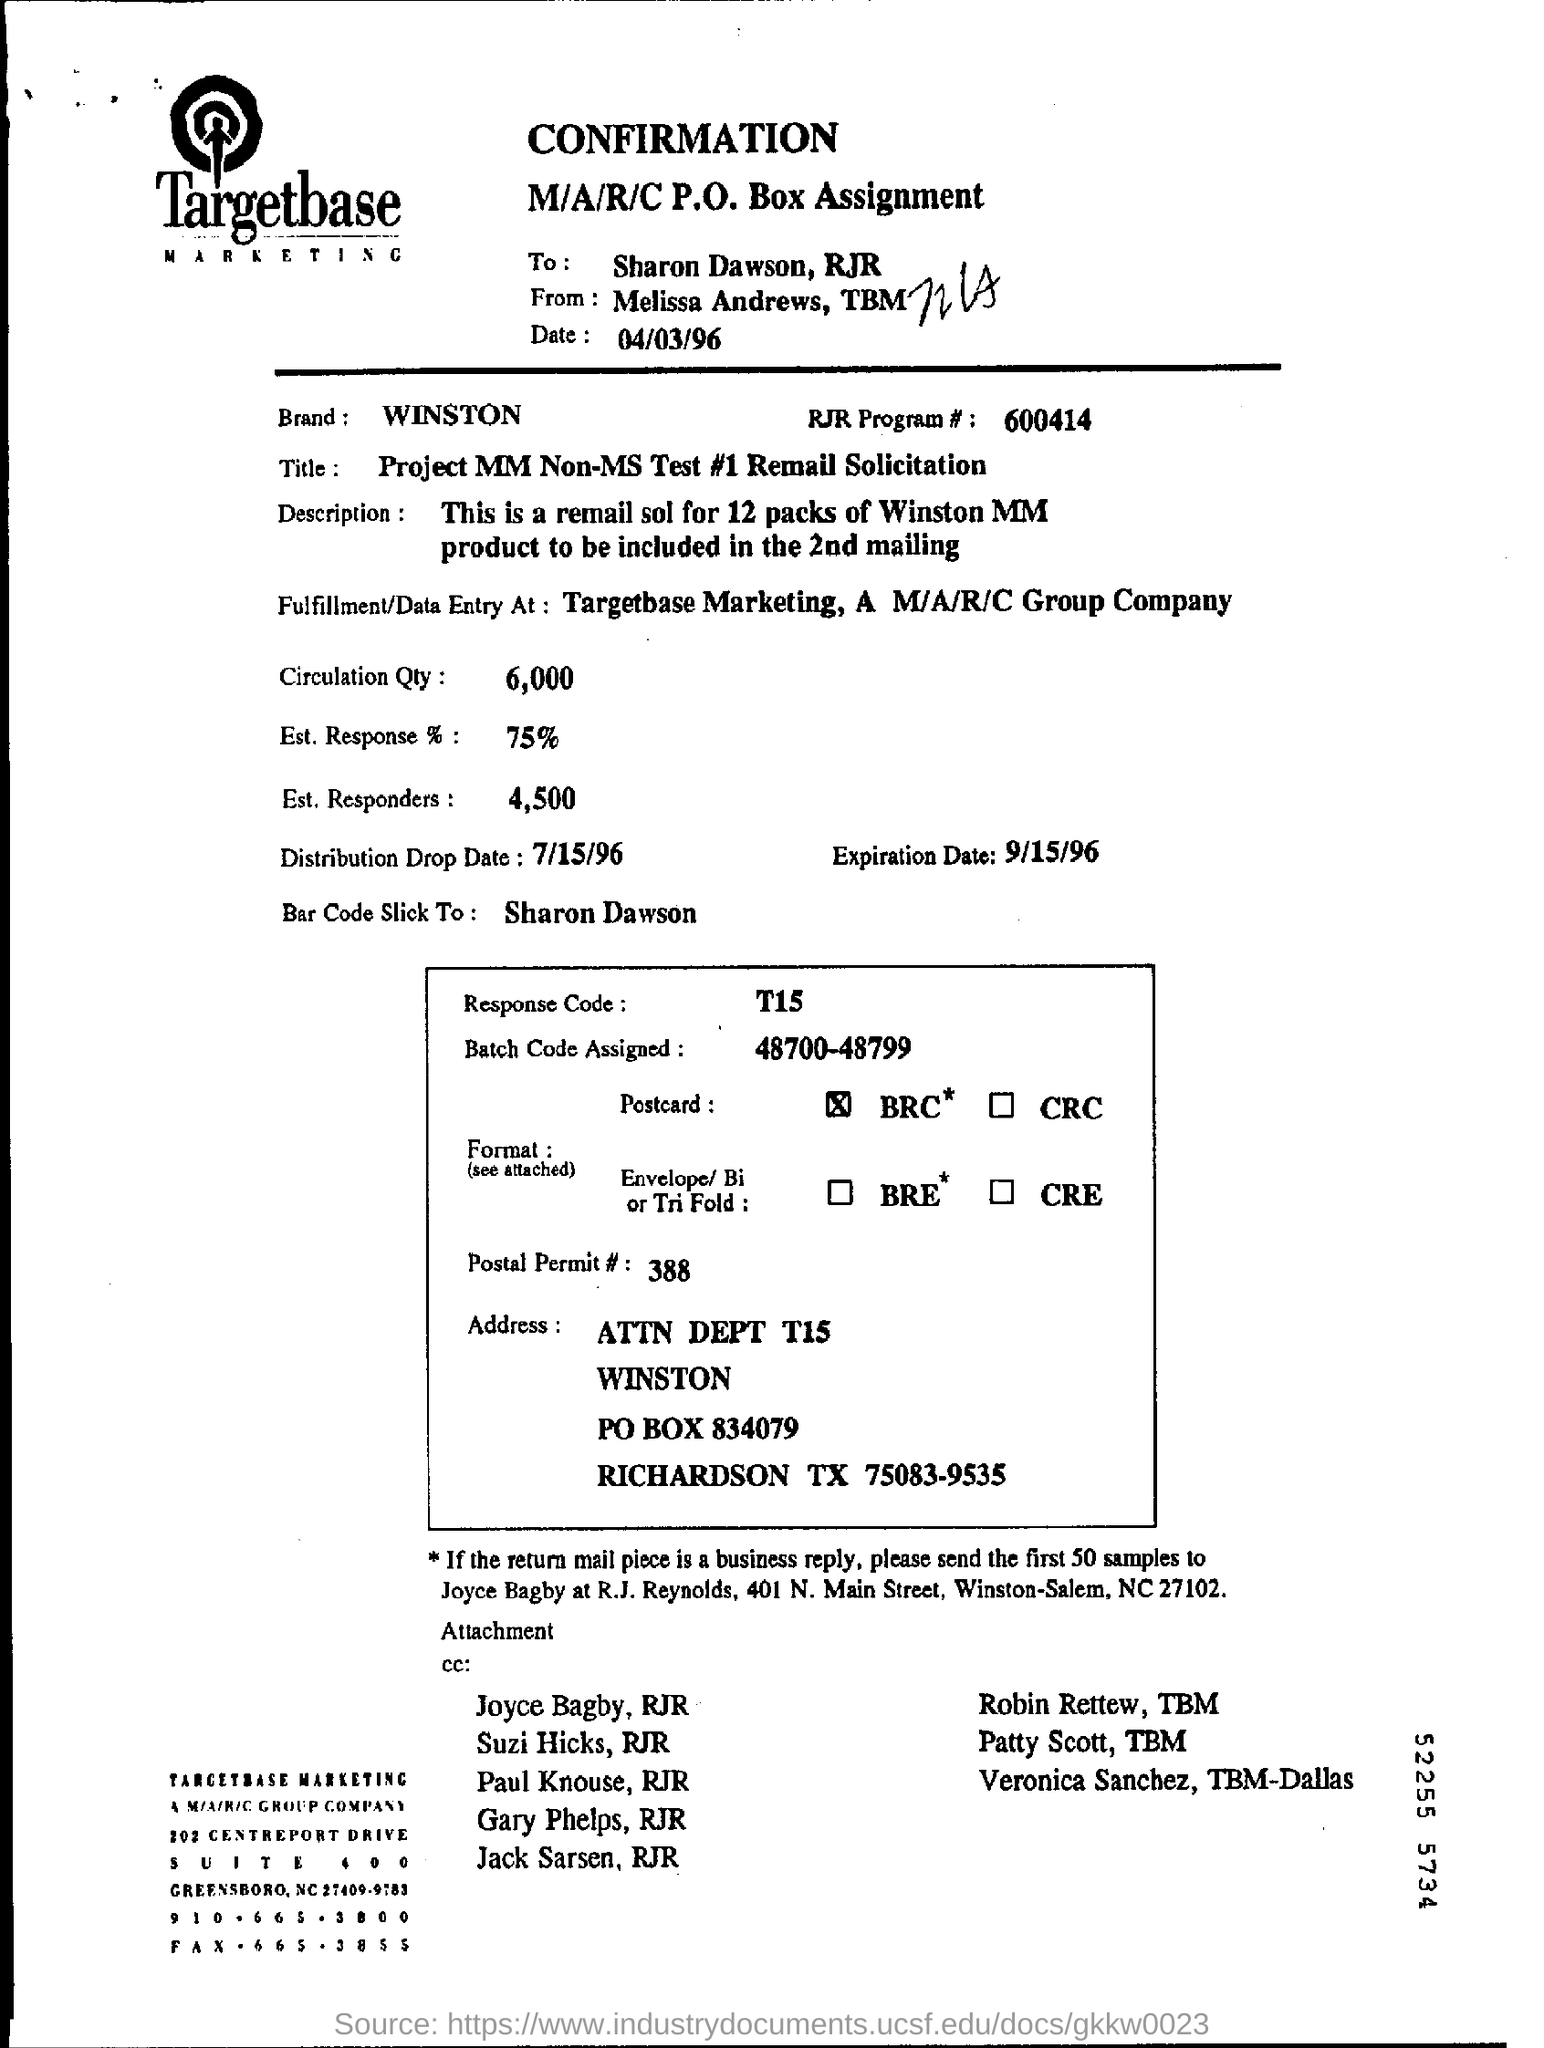Who is this from?
Offer a very short reply. Melissa. What is the date mentioned?
Keep it short and to the point. 04/03/96. Find out the name of Brand specified in this document?
Your response must be concise. WINSTON. What is the RJR Program #?
Your answer should be compact. 600414. What is the "title" ?
Your response must be concise. Project MM Non-MS Test #1 Remail Solicitation. Find out Circulation qty(quantity) from this page?
Your answer should be compact. 6,000. What is % of Est response?
Give a very brief answer. 75%. 